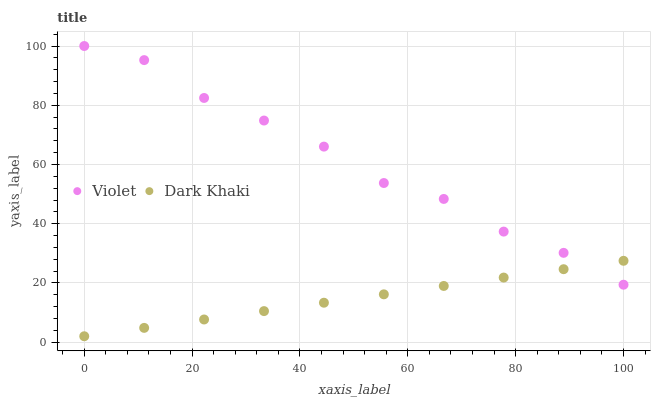Does Dark Khaki have the minimum area under the curve?
Answer yes or no. Yes. Does Violet have the maximum area under the curve?
Answer yes or no. Yes. Does Violet have the minimum area under the curve?
Answer yes or no. No. Is Dark Khaki the smoothest?
Answer yes or no. Yes. Is Violet the roughest?
Answer yes or no. Yes. Is Violet the smoothest?
Answer yes or no. No. Does Dark Khaki have the lowest value?
Answer yes or no. Yes. Does Violet have the lowest value?
Answer yes or no. No. Does Violet have the highest value?
Answer yes or no. Yes. Does Dark Khaki intersect Violet?
Answer yes or no. Yes. Is Dark Khaki less than Violet?
Answer yes or no. No. Is Dark Khaki greater than Violet?
Answer yes or no. No. 